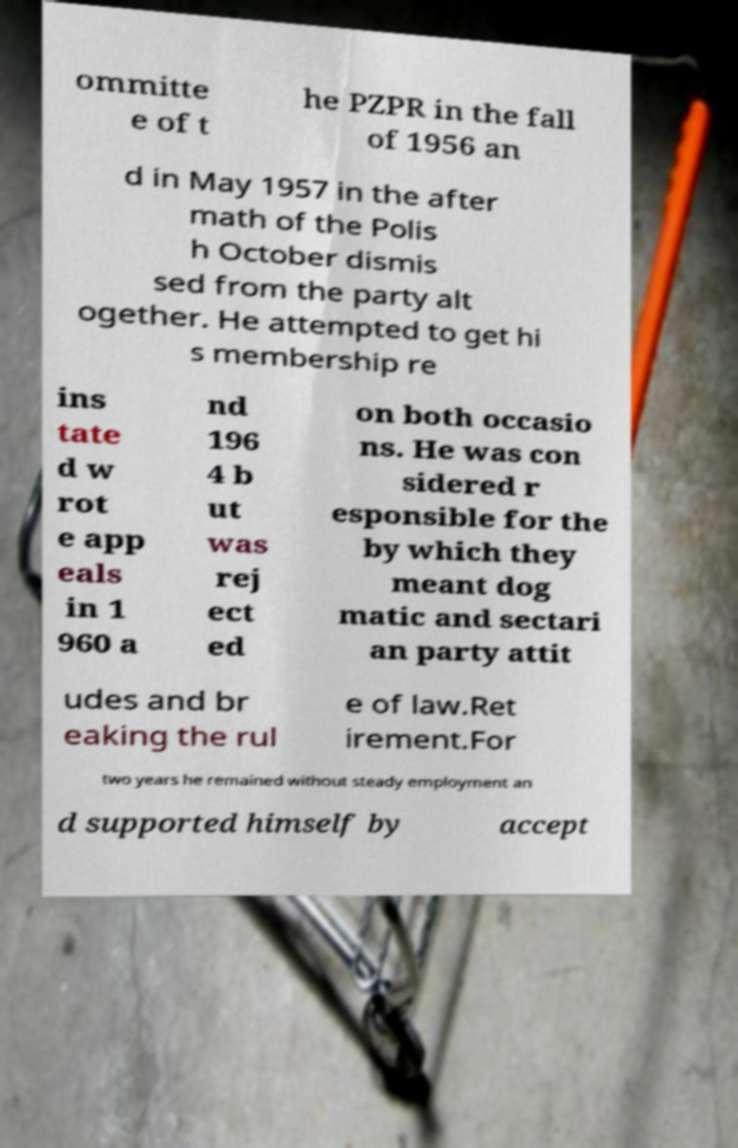What messages or text are displayed in this image? I need them in a readable, typed format. ommitte e of t he PZPR in the fall of 1956 an d in May 1957 in the after math of the Polis h October dismis sed from the party alt ogether. He attempted to get hi s membership re ins tate d w rot e app eals in 1 960 a nd 196 4 b ut was rej ect ed on both occasio ns. He was con sidered r esponsible for the by which they meant dog matic and sectari an party attit udes and br eaking the rul e of law.Ret irement.For two years he remained without steady employment an d supported himself by accept 